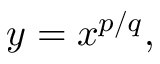Convert formula to latex. <formula><loc_0><loc_0><loc_500><loc_500>y = x ^ { p / q } ,</formula> 